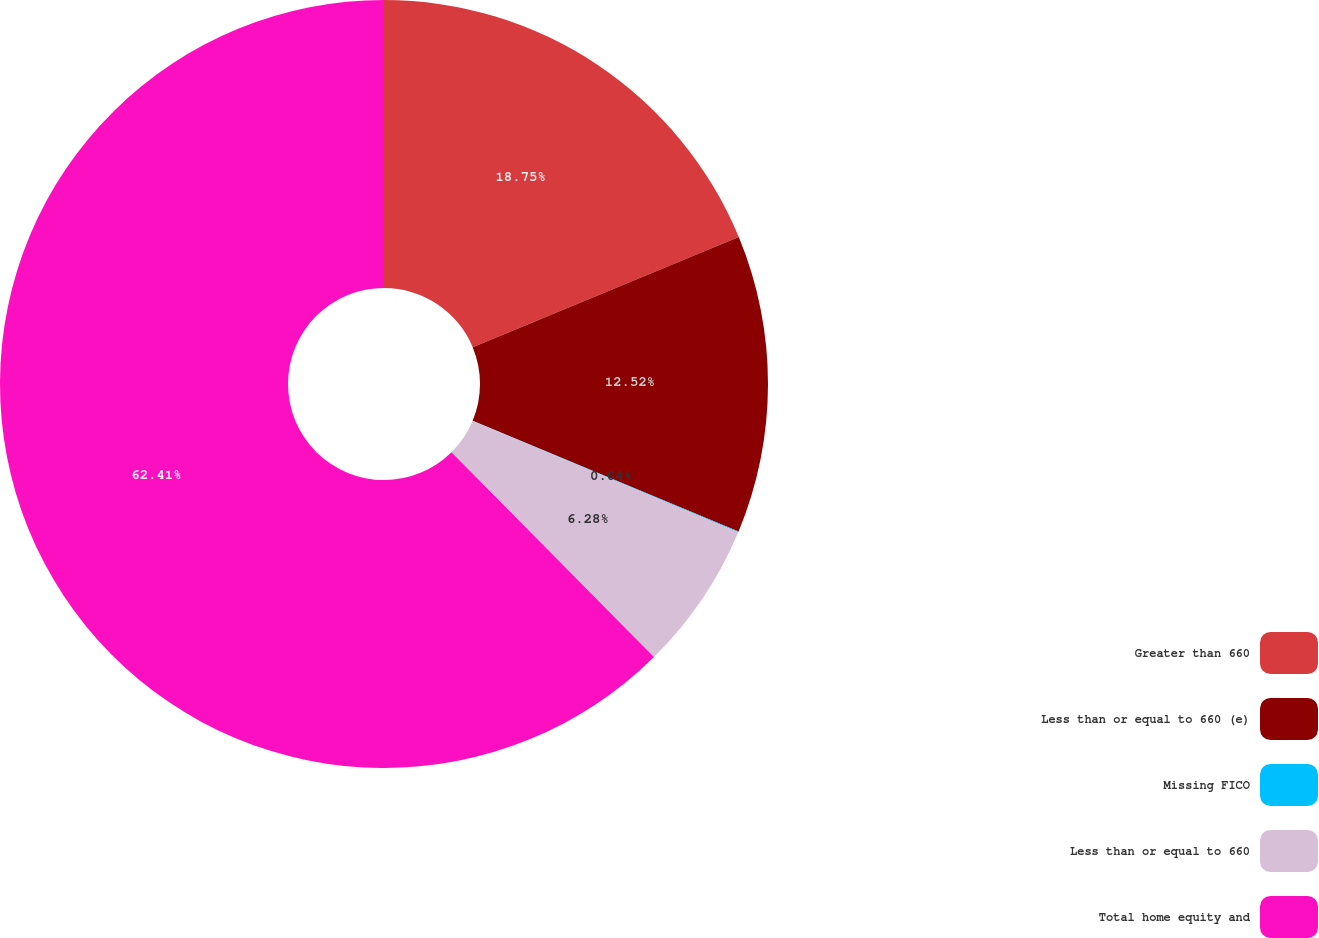Convert chart. <chart><loc_0><loc_0><loc_500><loc_500><pie_chart><fcel>Greater than 660<fcel>Less than or equal to 660 (e)<fcel>Missing FICO<fcel>Less than or equal to 660<fcel>Total home equity and<nl><fcel>18.75%<fcel>12.52%<fcel>0.04%<fcel>6.28%<fcel>62.41%<nl></chart> 